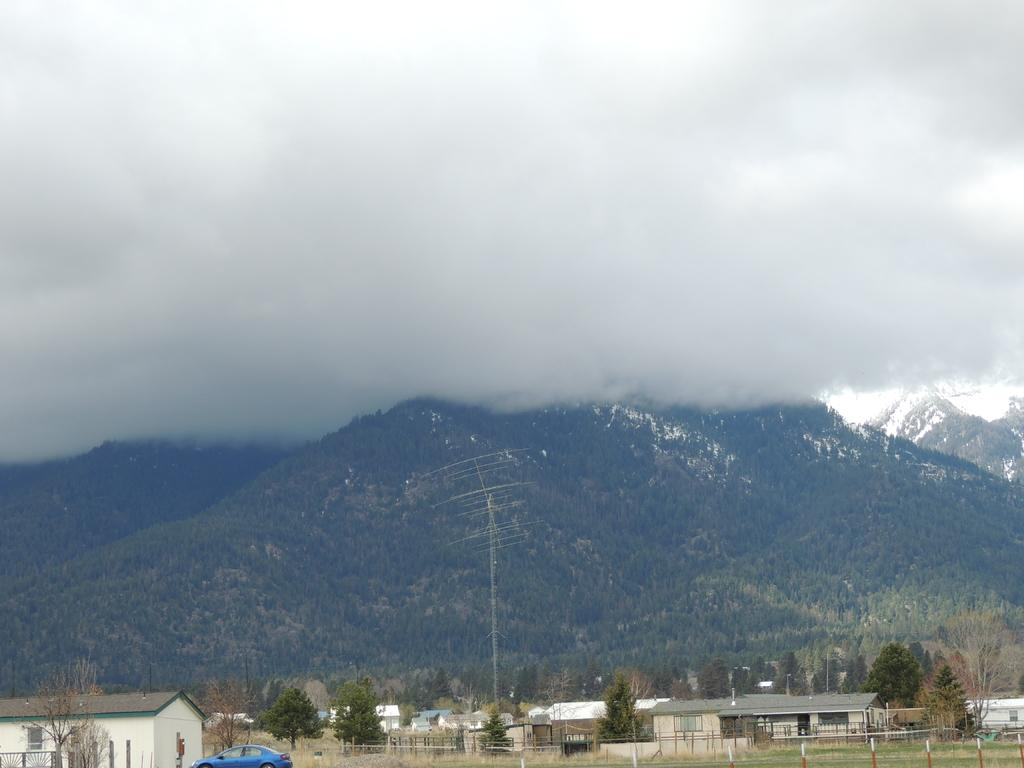What can be seen in the sky in the image? There are clouds in the image. What type of natural formation is visible in the image? There are mountains in the image. What is located in front of the mountains? Trees, houses, a fence, and a vehicle are present in front of the mountains. What man-made structure is visible in the image? There is a signal tower in the image. Can you tell me how many trees are supporting the signal tower in the image? There are no trees supporting the signal tower in the image; the tower is a separate structure. What type of tree is bursting through the fence in the image? There is no tree bursting through the fence in the image; the fence is separate from the trees. 